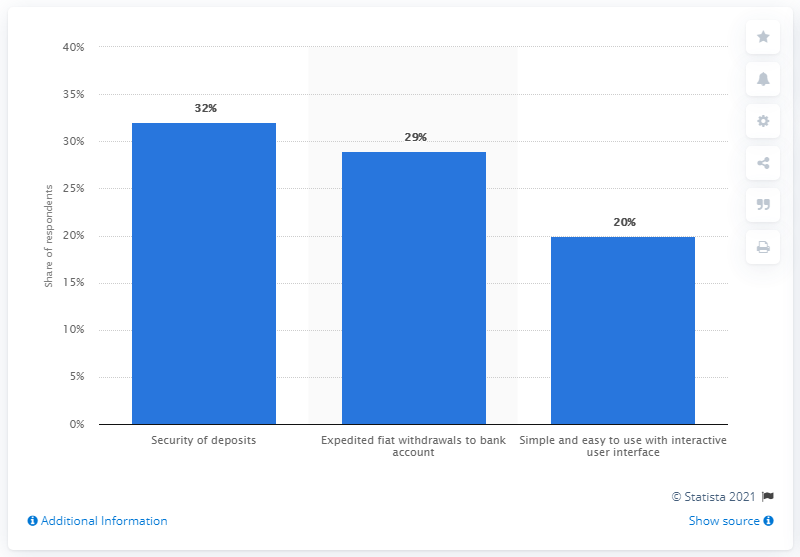Identify some key points in this picture. Encrybit's survey on real-time cryptocurrency exchange problems reveals insights into the issues faced by users, with a total of 32 reported problems. 